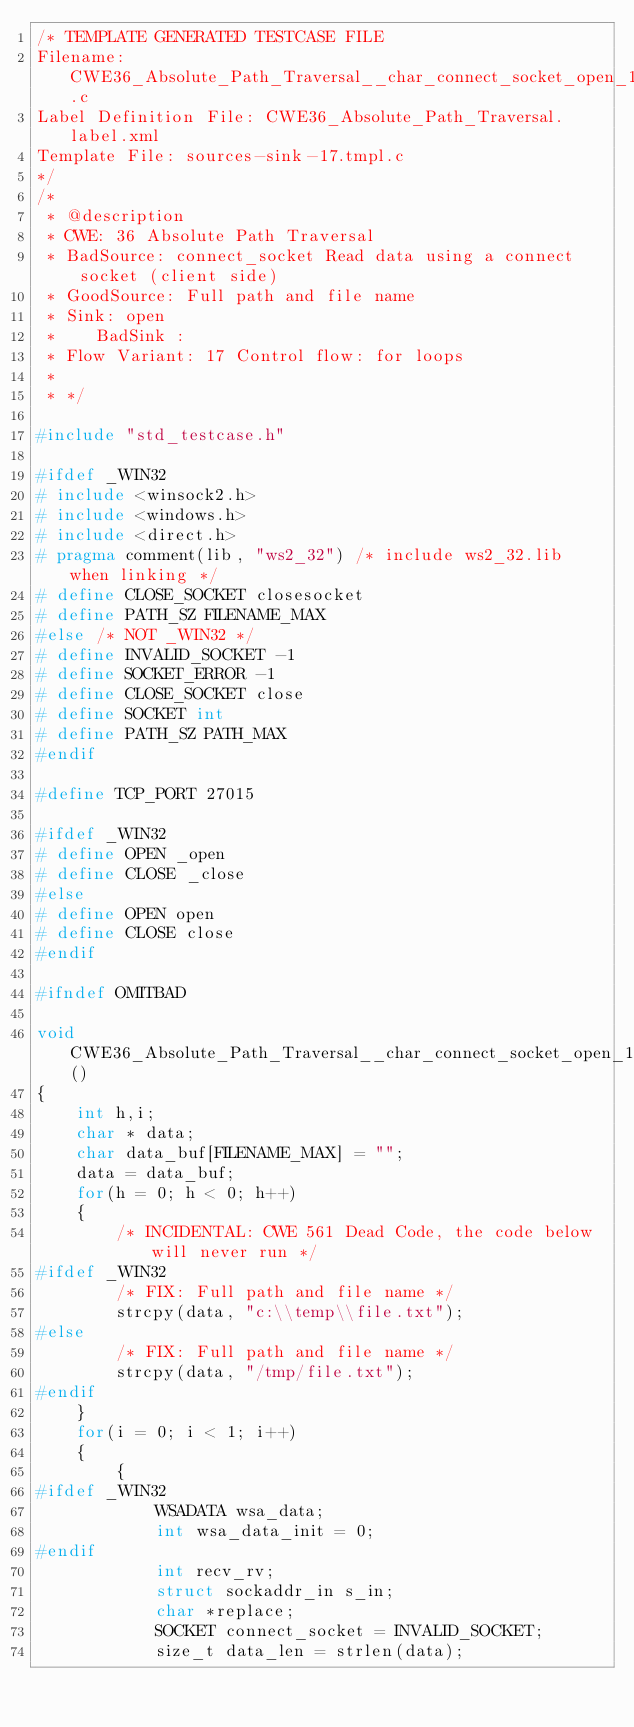<code> <loc_0><loc_0><loc_500><loc_500><_C_>/* TEMPLATE GENERATED TESTCASE FILE
Filename: CWE36_Absolute_Path_Traversal__char_connect_socket_open_17.c
Label Definition File: CWE36_Absolute_Path_Traversal.label.xml
Template File: sources-sink-17.tmpl.c
*/
/*
 * @description
 * CWE: 36 Absolute Path Traversal
 * BadSource: connect_socket Read data using a connect socket (client side)
 * GoodSource: Full path and file name
 * Sink: open
 *    BadSink :
 * Flow Variant: 17 Control flow: for loops
 *
 * */

#include "std_testcase.h"

#ifdef _WIN32
# include <winsock2.h>
# include <windows.h>
# include <direct.h>
# pragma comment(lib, "ws2_32") /* include ws2_32.lib when linking */
# define CLOSE_SOCKET closesocket
# define PATH_SZ FILENAME_MAX
#else /* NOT _WIN32 */
# define INVALID_SOCKET -1
# define SOCKET_ERROR -1
# define CLOSE_SOCKET close
# define SOCKET int
# define PATH_SZ PATH_MAX
#endif

#define TCP_PORT 27015

#ifdef _WIN32
# define OPEN _open
# define CLOSE _close
#else
# define OPEN open
# define CLOSE close
#endif

#ifndef OMITBAD

void CWE36_Absolute_Path_Traversal__char_connect_socket_open_17_bad()
{
    int h,i;
    char * data;
    char data_buf[FILENAME_MAX] = "";
    data = data_buf;
    for(h = 0; h < 0; h++)
    {
        /* INCIDENTAL: CWE 561 Dead Code, the code below will never run */
#ifdef _WIN32
        /* FIX: Full path and file name */
        strcpy(data, "c:\\temp\\file.txt");
#else
        /* FIX: Full path and file name */
        strcpy(data, "/tmp/file.txt");
#endif
    }
    for(i = 0; i < 1; i++)
    {
        {
#ifdef _WIN32
            WSADATA wsa_data;
            int wsa_data_init = 0;
#endif
            int recv_rv;
            struct sockaddr_in s_in;
            char *replace;
            SOCKET connect_socket = INVALID_SOCKET;
            size_t data_len = strlen(data);</code> 